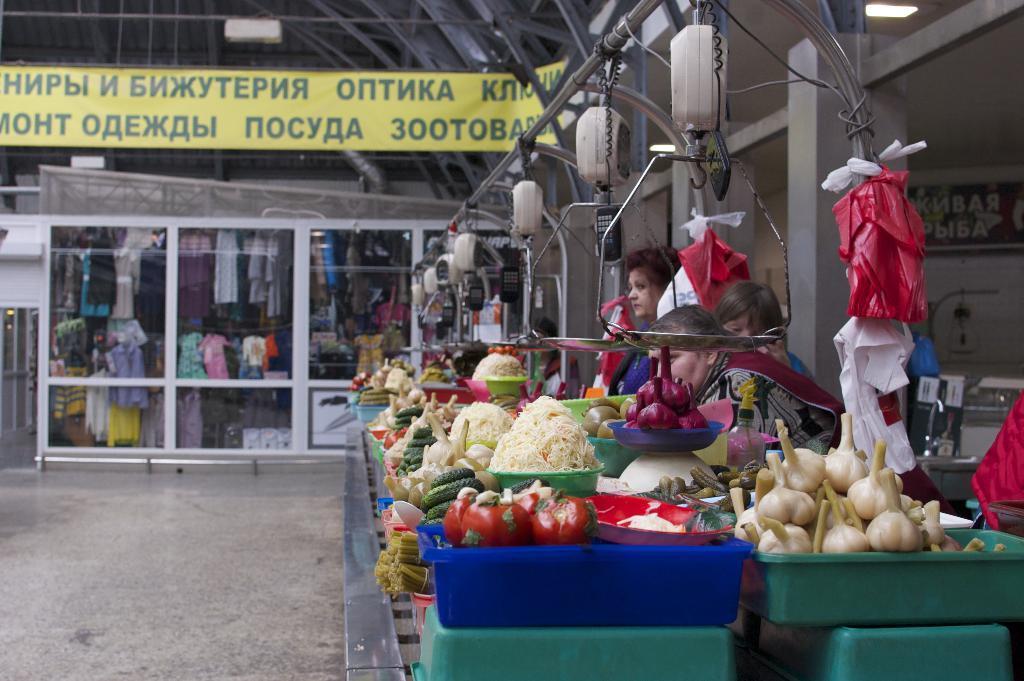How would you summarize this image in a sentence or two? On the right side of the image we can see some vegetables, containers, weight machine, plastic covers and some persons, wall are there. In the center of the image we can see some clothes are present. At the top of the image roof, board are there. At the bottom of the image floor is present. 